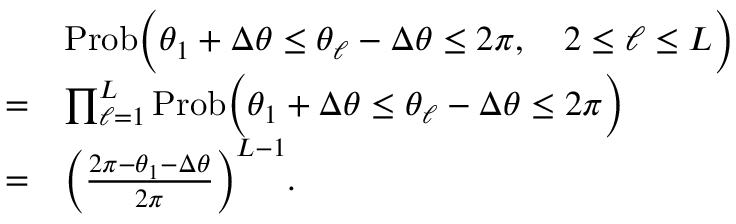<formula> <loc_0><loc_0><loc_500><loc_500>\begin{array} { r l } & { P r o b \left ( \theta _ { 1 } + \Delta \theta \leq \theta _ { \ell } - \Delta \theta \leq 2 \pi , \quad 2 \leq \ell \leq L \right ) } \\ { = } & { \prod _ { \ell = 1 } ^ { L } P r o b \left ( \theta _ { 1 } + \Delta \theta \leq \theta _ { \ell } - \Delta \theta \leq 2 \pi \right ) } \\ { = } & { \left ( \frac { 2 \pi - \theta _ { 1 } - \Delta \theta } { 2 \pi } \right ) ^ { L - 1 } . } \end{array}</formula> 